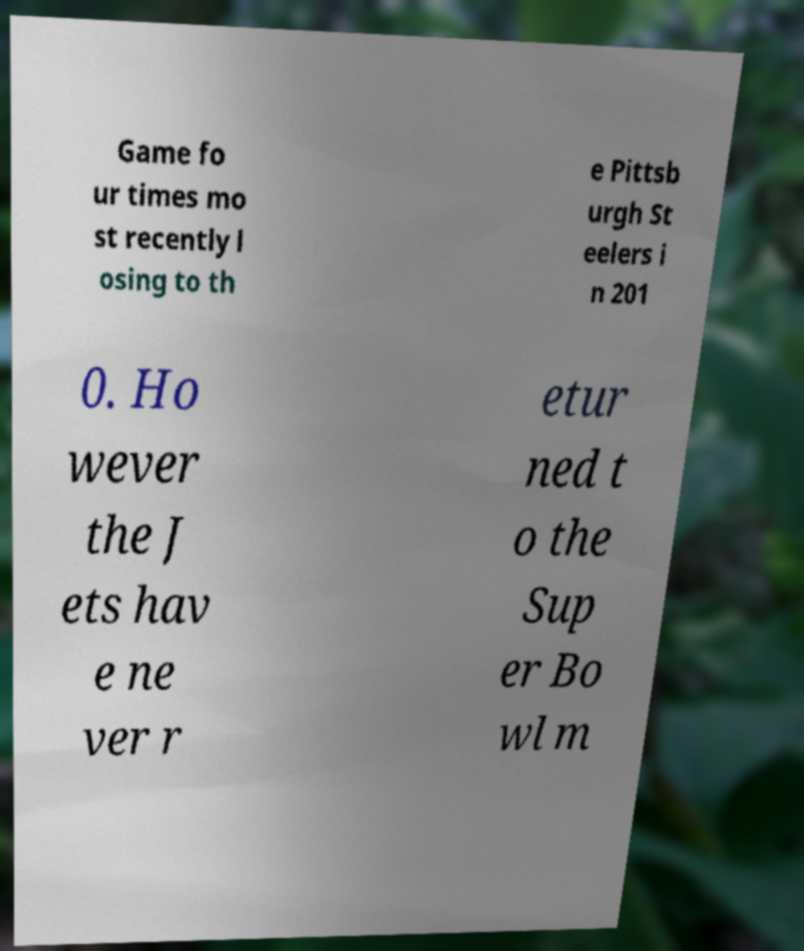For documentation purposes, I need the text within this image transcribed. Could you provide that? Game fo ur times mo st recently l osing to th e Pittsb urgh St eelers i n 201 0. Ho wever the J ets hav e ne ver r etur ned t o the Sup er Bo wl m 